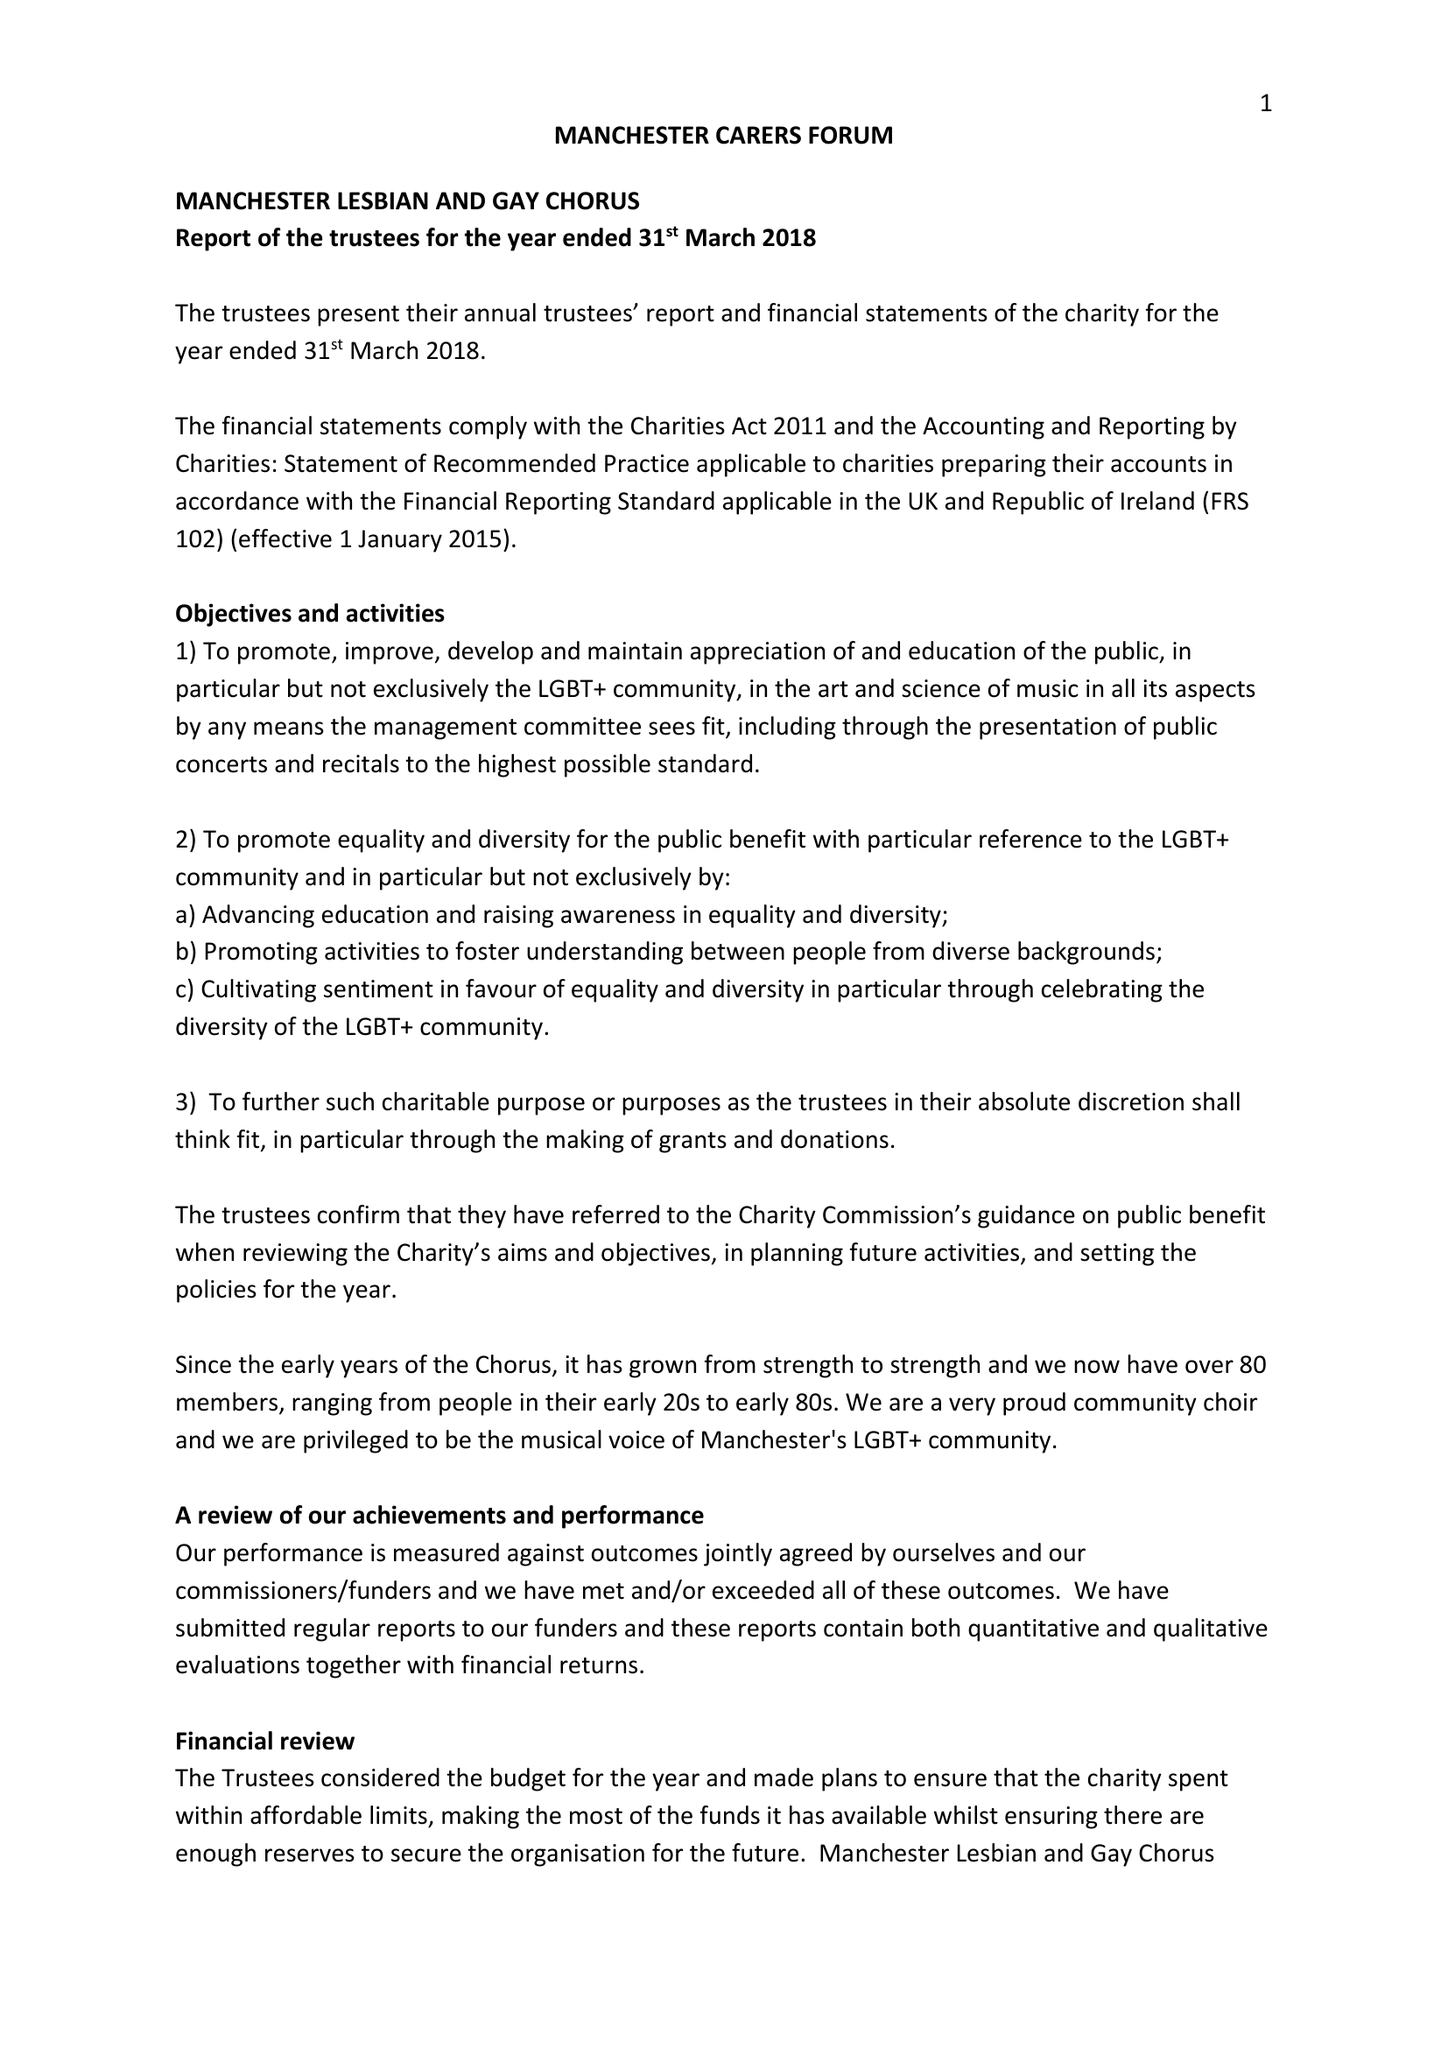What is the value for the spending_annually_in_british_pounds?
Answer the question using a single word or phrase. 20376.00 